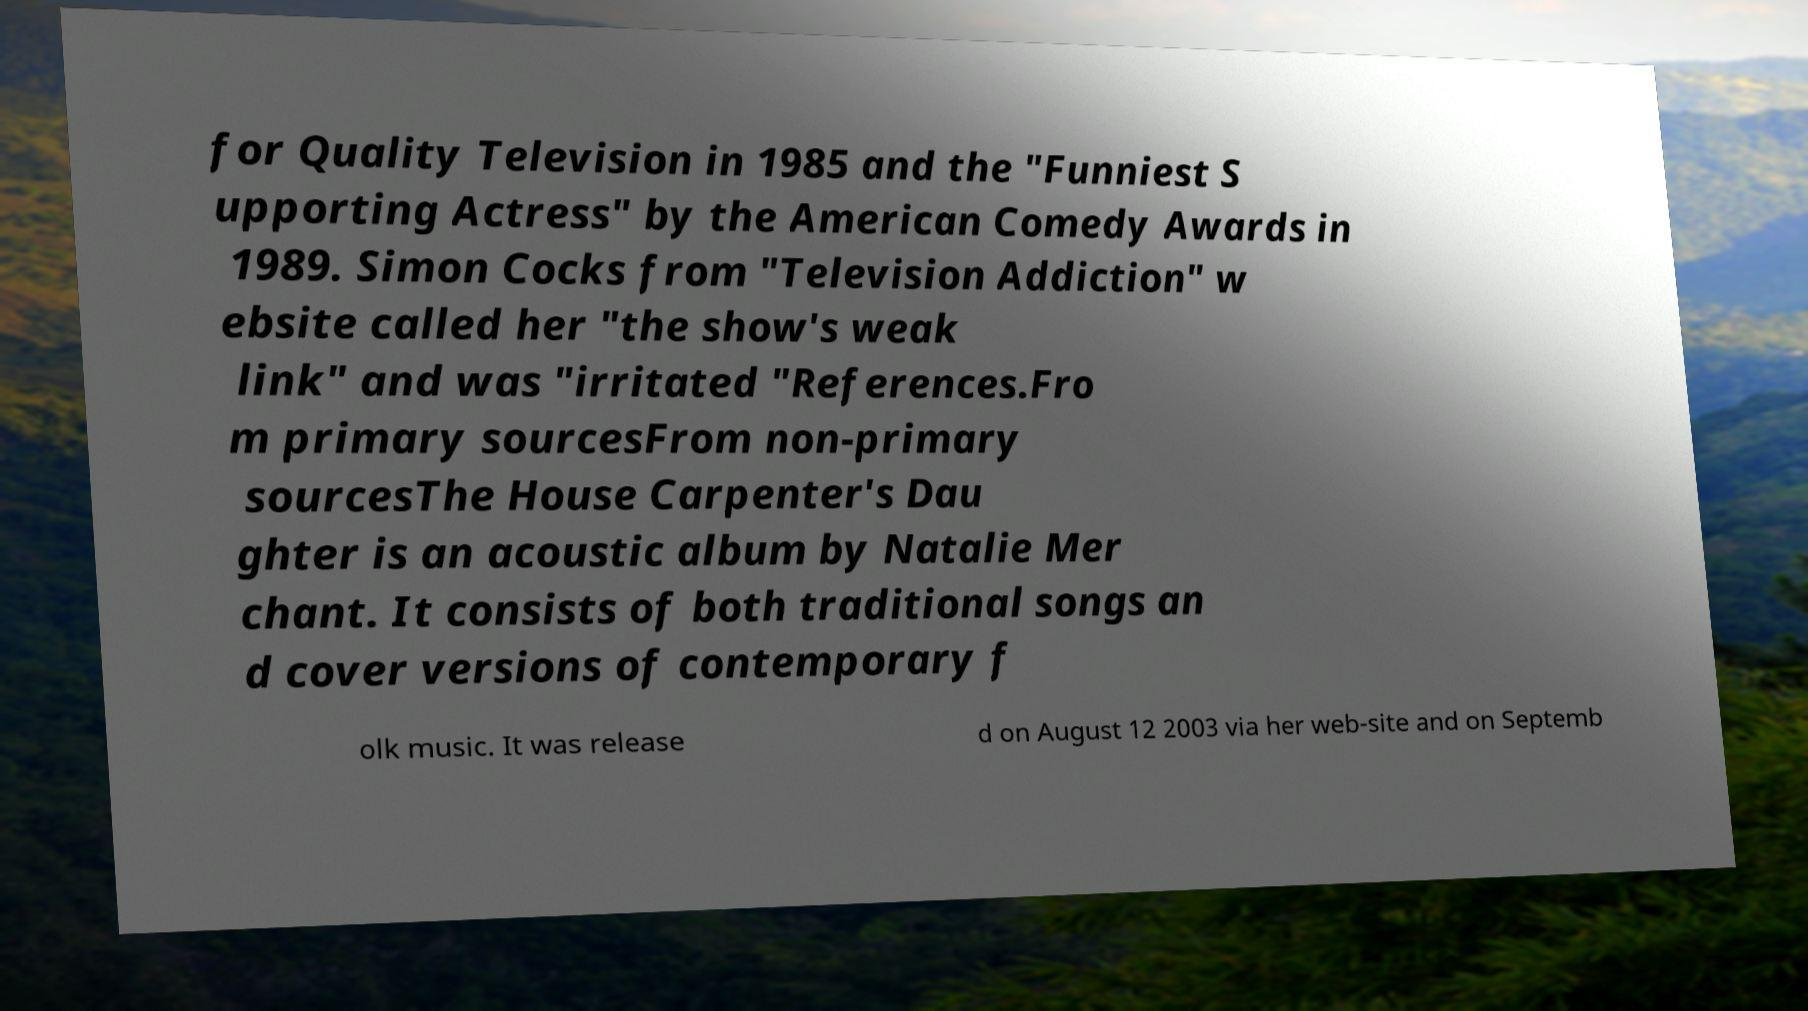I need the written content from this picture converted into text. Can you do that? for Quality Television in 1985 and the "Funniest S upporting Actress" by the American Comedy Awards in 1989. Simon Cocks from "Television Addiction" w ebsite called her "the show's weak link" and was "irritated "References.Fro m primary sourcesFrom non-primary sourcesThe House Carpenter's Dau ghter is an acoustic album by Natalie Mer chant. It consists of both traditional songs an d cover versions of contemporary f olk music. It was release d on August 12 2003 via her web-site and on Septemb 